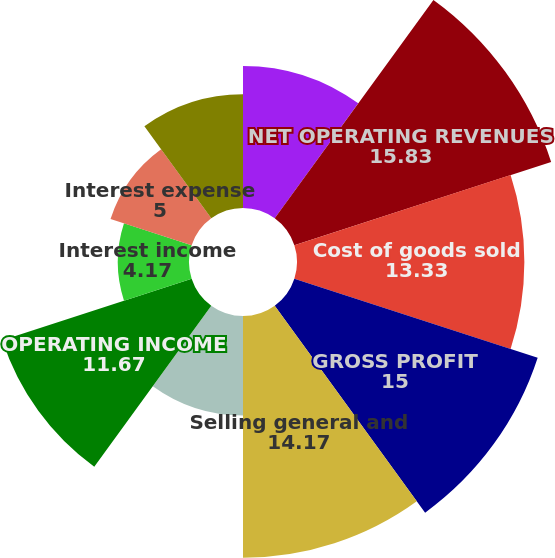Convert chart to OTSL. <chart><loc_0><loc_0><loc_500><loc_500><pie_chart><fcel>Year Ended December 31<fcel>NET OPERATING REVENUES<fcel>Cost of goods sold<fcel>GROSS PROFIT<fcel>Selling general and<fcel>Other operating charges<fcel>OPERATING INCOME<fcel>Interest income<fcel>Interest expense<fcel>Equity income - net<nl><fcel>8.33%<fcel>15.83%<fcel>13.33%<fcel>15.0%<fcel>14.17%<fcel>5.83%<fcel>11.67%<fcel>4.17%<fcel>5.0%<fcel>6.67%<nl></chart> 